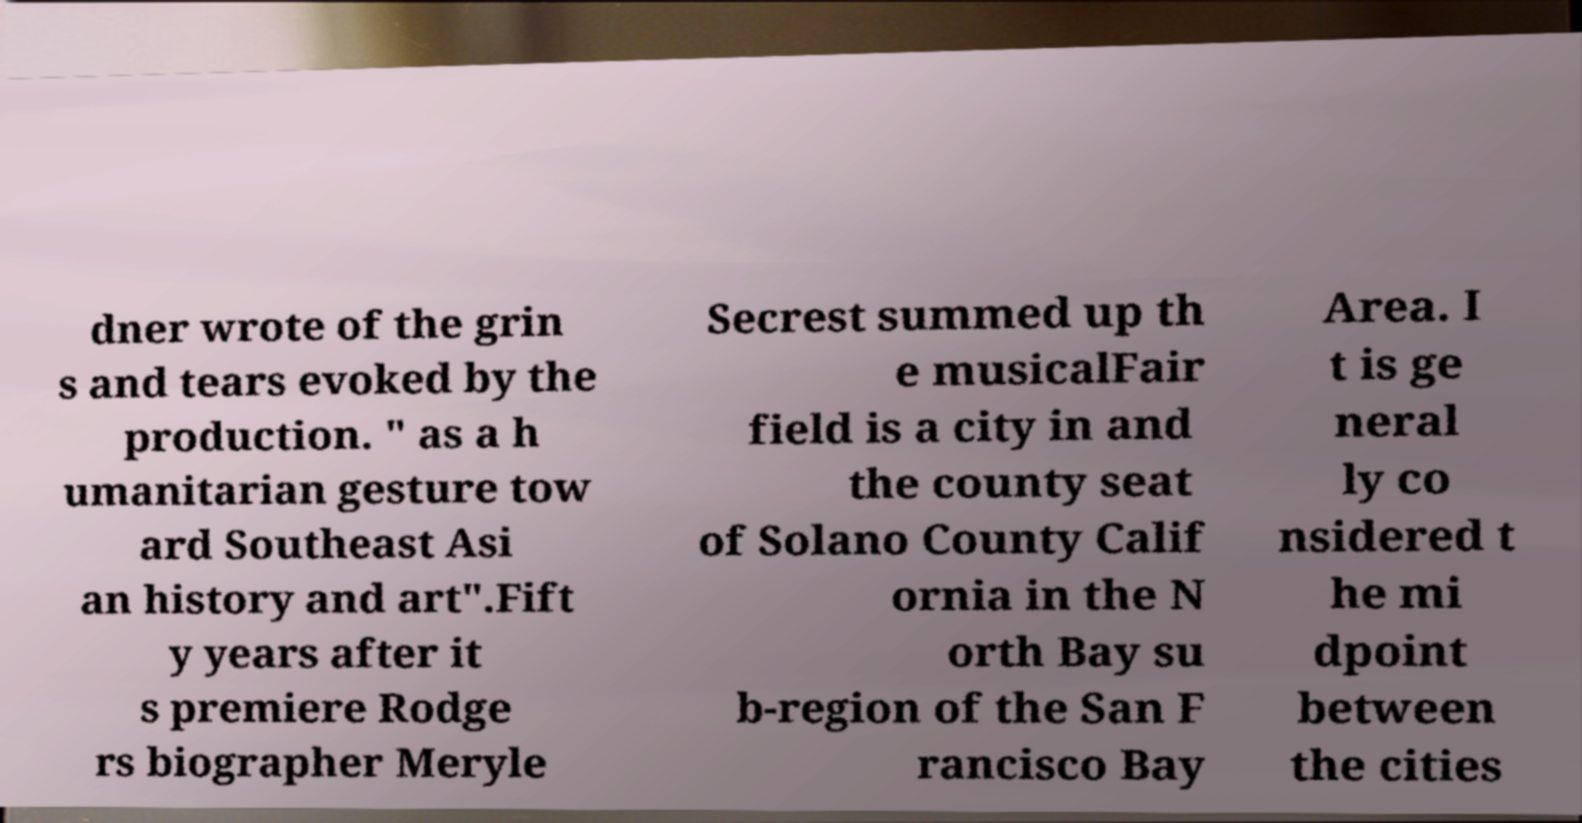What messages or text are displayed in this image? I need them in a readable, typed format. dner wrote of the grin s and tears evoked by the production. " as a h umanitarian gesture tow ard Southeast Asi an history and art".Fift y years after it s premiere Rodge rs biographer Meryle Secrest summed up th e musicalFair field is a city in and the county seat of Solano County Calif ornia in the N orth Bay su b-region of the San F rancisco Bay Area. I t is ge neral ly co nsidered t he mi dpoint between the cities 